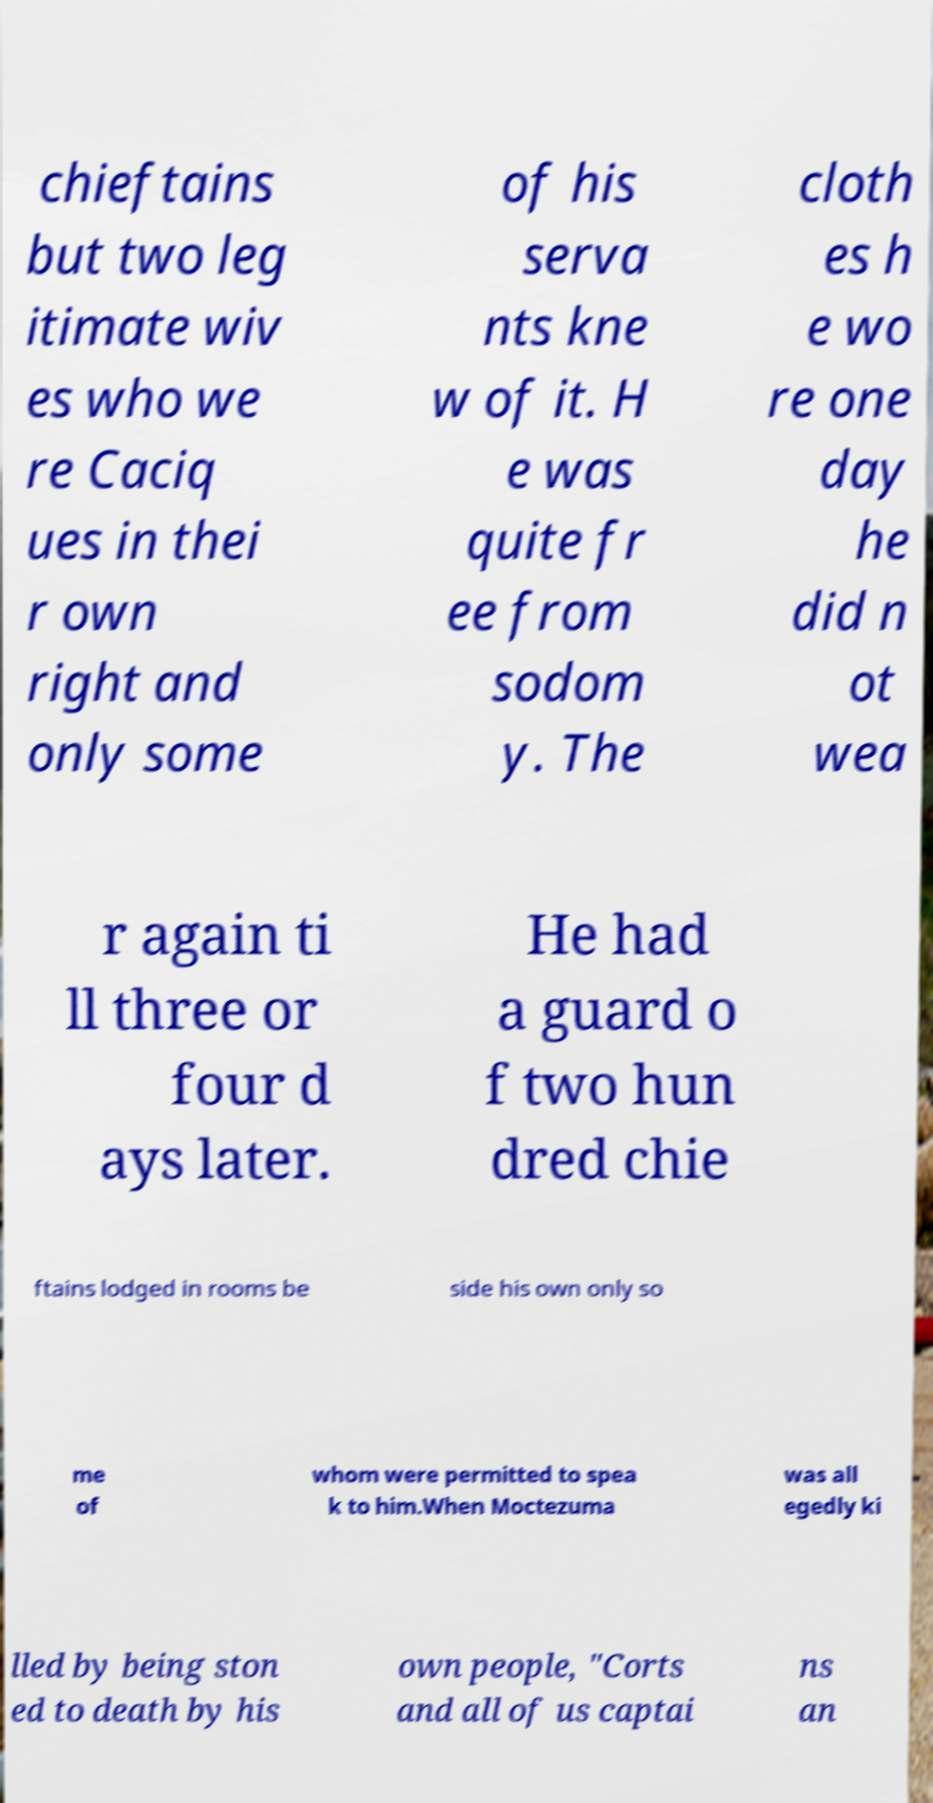Can you accurately transcribe the text from the provided image for me? chieftains but two leg itimate wiv es who we re Caciq ues in thei r own right and only some of his serva nts kne w of it. H e was quite fr ee from sodom y. The cloth es h e wo re one day he did n ot wea r again ti ll three or four d ays later. He had a guard o f two hun dred chie ftains lodged in rooms be side his own only so me of whom were permitted to spea k to him.When Moctezuma was all egedly ki lled by being ston ed to death by his own people, "Corts and all of us captai ns an 